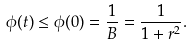Convert formula to latex. <formula><loc_0><loc_0><loc_500><loc_500>\phi ( t ) \leq \phi ( 0 ) = \frac { 1 } { B } = \frac { 1 } { 1 + r ^ { 2 } } .</formula> 